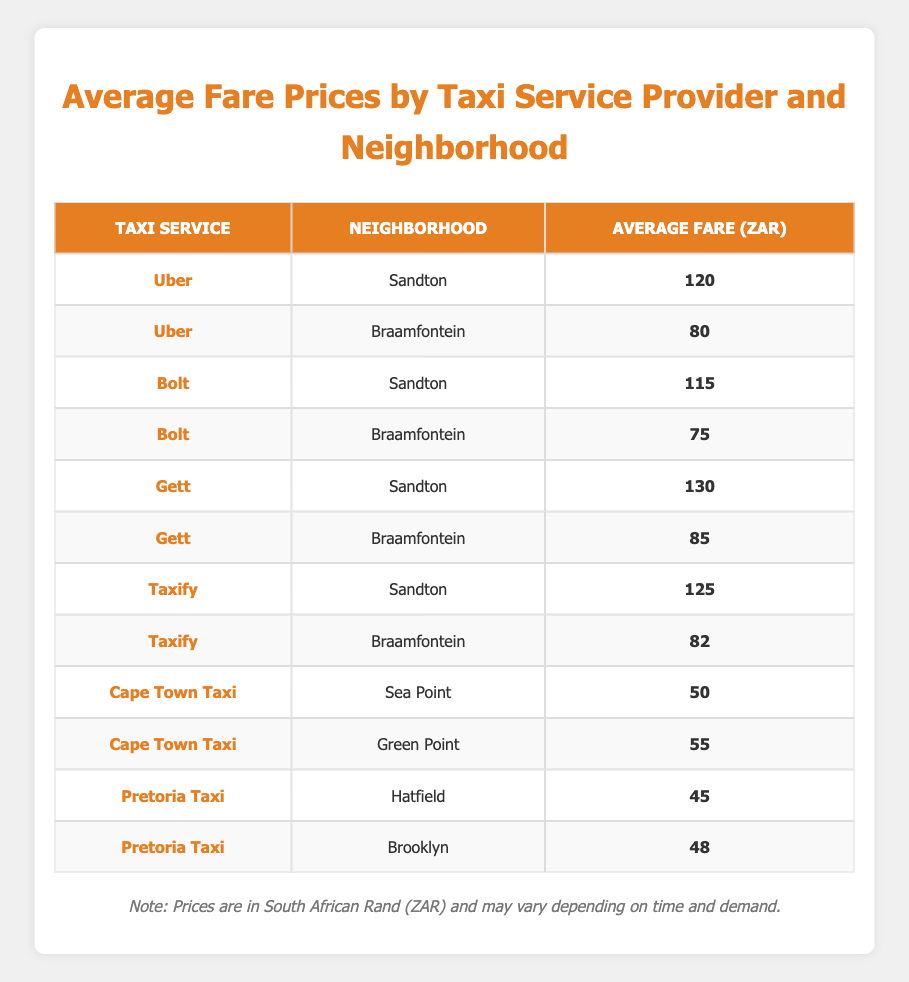What is the average fare for Uber in Sandton? The table shows that the average fare for Uber in Sandton is 120 ZAR, as stated in the relevant row.
Answer: 120 ZAR Which taxi service provider has the lowest average fare in Braamfontein? By comparing the average fares for the services listed under Braamfontein, Bolt has the lowest average fare of 75 ZAR.
Answer: Bolt What is the average fare for a trip using Taxify in Sandton and Braamfontein combined? For Taxify, the average fare in Sandton is 125 ZAR and in Braamfontein is 82 ZAR. Their combined average is (125 + 82) / 2 = 103.5 ZAR.
Answer: 103.5 ZAR Is the average fare for Gett higher in Sandton than in Braamfontein? The average fare for Gett in Sandton is 130 ZAR, while in Braamfontein it is 85 ZAR. Since 130 is greater than 85, the answer is yes.
Answer: Yes Which neighborhood has the highest average fare among the listed taxi services? Checking the highest fares in Sandton and Braamfontein, Gett in Sandton has the highest fare at 130 ZAR compared to all other services. Therefore, Sandton has the highest average fare.
Answer: Sandton What is the total average fare for all taxi services listed in Sea Point? The only taxi service mentioned in Sea Point is Cape Town Taxi with an average fare of 50 ZAR. Therefore, the total average fare for Sea Point is 50 ZAR.
Answer: 50 ZAR Does the average fare for Pretoria Taxi in Hatfield exceed 50 ZAR? The average fare for Pretoria Taxi in Hatfield is 45 ZAR, which does not exceed 50 ZAR. Thus, the answer is no.
Answer: No Which taxi service has a higher average fare in Braamfontein, Uber or Taxify? The average fare for Uber in Braamfontein is 80 ZAR and for Taxify is 82 ZAR. Since 82 is greater than 80, Taxify has a higher average fare in Braamfontein.
Answer: Taxify 